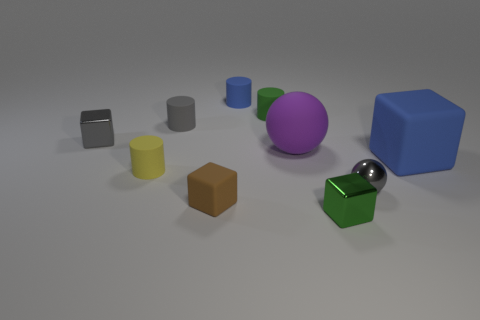Subtract all cylinders. How many objects are left? 6 Subtract 1 green cubes. How many objects are left? 9 Subtract all blue rubber objects. Subtract all green objects. How many objects are left? 6 Add 7 blue matte objects. How many blue matte objects are left? 9 Add 4 big green rubber spheres. How many big green rubber spheres exist? 4 